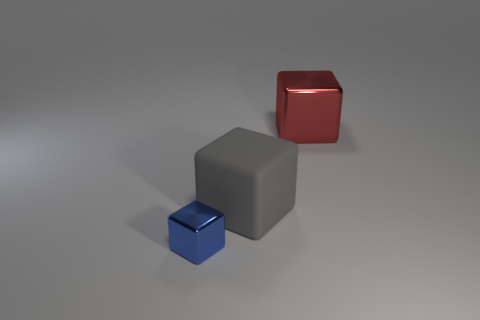There is a blue metallic cube; are there any cubes to the right of it?
Make the answer very short. Yes. What number of things are objects behind the gray rubber thing or gray rubber things?
Offer a terse response. 2. What number of blue things are on the left side of the thing behind the gray rubber object?
Make the answer very short. 1. Are there fewer gray cubes that are left of the gray cube than cubes behind the blue metal cube?
Keep it short and to the point. Yes. There is a shiny object that is right of the metallic object that is to the left of the red metal block; what shape is it?
Offer a terse response. Cube. How many other things are there of the same material as the red object?
Make the answer very short. 1. Is there any other thing that has the same size as the blue thing?
Make the answer very short. No. Are there more gray cubes than yellow matte things?
Give a very brief answer. Yes. What is the size of the gray block left of the red metal thing to the right of the big object in front of the big red metallic object?
Keep it short and to the point. Large. There is a gray rubber cube; is its size the same as the cube that is behind the matte thing?
Make the answer very short. Yes. 